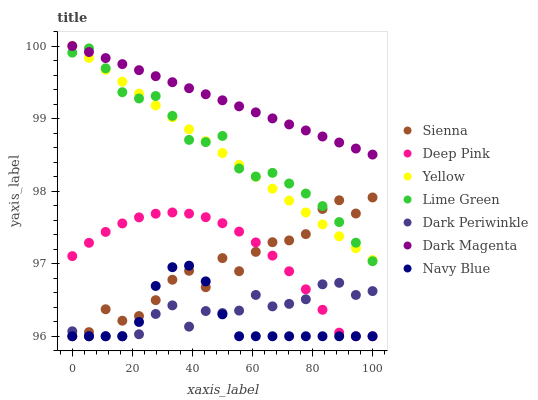Does Navy Blue have the minimum area under the curve?
Answer yes or no. Yes. Does Dark Magenta have the maximum area under the curve?
Answer yes or no. Yes. Does Dark Magenta have the minimum area under the curve?
Answer yes or no. No. Does Navy Blue have the maximum area under the curve?
Answer yes or no. No. Is Yellow the smoothest?
Answer yes or no. Yes. Is Sienna the roughest?
Answer yes or no. Yes. Is Dark Magenta the smoothest?
Answer yes or no. No. Is Dark Magenta the roughest?
Answer yes or no. No. Does Deep Pink have the lowest value?
Answer yes or no. Yes. Does Dark Magenta have the lowest value?
Answer yes or no. No. Does Yellow have the highest value?
Answer yes or no. Yes. Does Navy Blue have the highest value?
Answer yes or no. No. Is Deep Pink less than Yellow?
Answer yes or no. Yes. Is Dark Magenta greater than Deep Pink?
Answer yes or no. Yes. Does Dark Magenta intersect Lime Green?
Answer yes or no. Yes. Is Dark Magenta less than Lime Green?
Answer yes or no. No. Is Dark Magenta greater than Lime Green?
Answer yes or no. No. Does Deep Pink intersect Yellow?
Answer yes or no. No. 